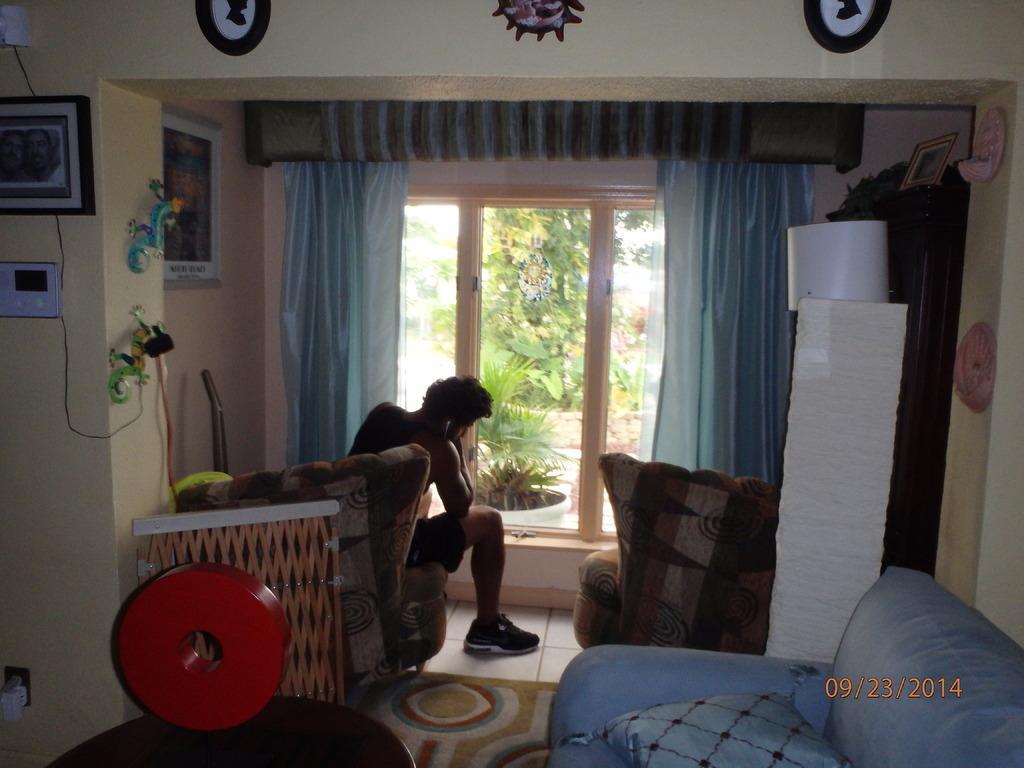Could you give a brief overview of what you see in this image? In this image I can see a man is sitting on a couch. I can also see a sofa and a cushion on it. In the background I can see curtains, few frames on this wall and few plants. 